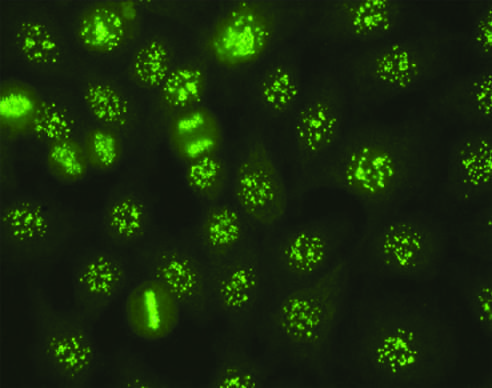re genes that encode several proteins involved in antigen processing seen in some cases of systemic sclerosis, sjogren syndrome, and other diseases?
Answer the question using a single word or phrase. No 